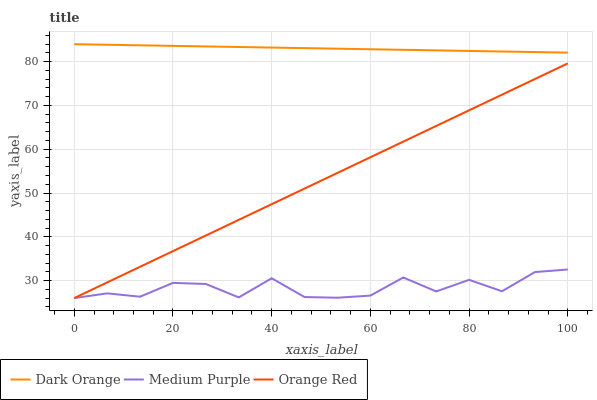Does Medium Purple have the minimum area under the curve?
Answer yes or no. Yes. Does Dark Orange have the maximum area under the curve?
Answer yes or no. Yes. Does Orange Red have the minimum area under the curve?
Answer yes or no. No. Does Orange Red have the maximum area under the curve?
Answer yes or no. No. Is Dark Orange the smoothest?
Answer yes or no. Yes. Is Medium Purple the roughest?
Answer yes or no. Yes. Is Orange Red the smoothest?
Answer yes or no. No. Is Orange Red the roughest?
Answer yes or no. No. Does Medium Purple have the lowest value?
Answer yes or no. Yes. Does Dark Orange have the lowest value?
Answer yes or no. No. Does Dark Orange have the highest value?
Answer yes or no. Yes. Does Orange Red have the highest value?
Answer yes or no. No. Is Orange Red less than Dark Orange?
Answer yes or no. Yes. Is Dark Orange greater than Medium Purple?
Answer yes or no. Yes. Does Medium Purple intersect Orange Red?
Answer yes or no. Yes. Is Medium Purple less than Orange Red?
Answer yes or no. No. Is Medium Purple greater than Orange Red?
Answer yes or no. No. Does Orange Red intersect Dark Orange?
Answer yes or no. No. 